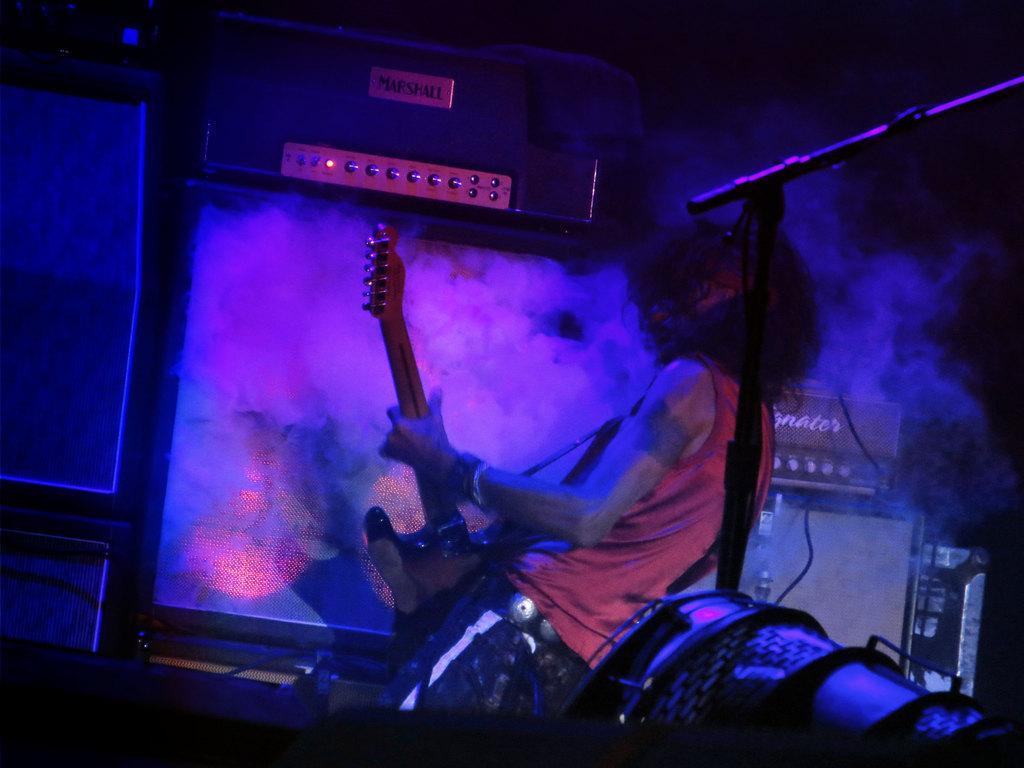Please provide a concise description of this image. In this picture there is a man standing and playing a guitar in his hands. In the background there is a smoke. 